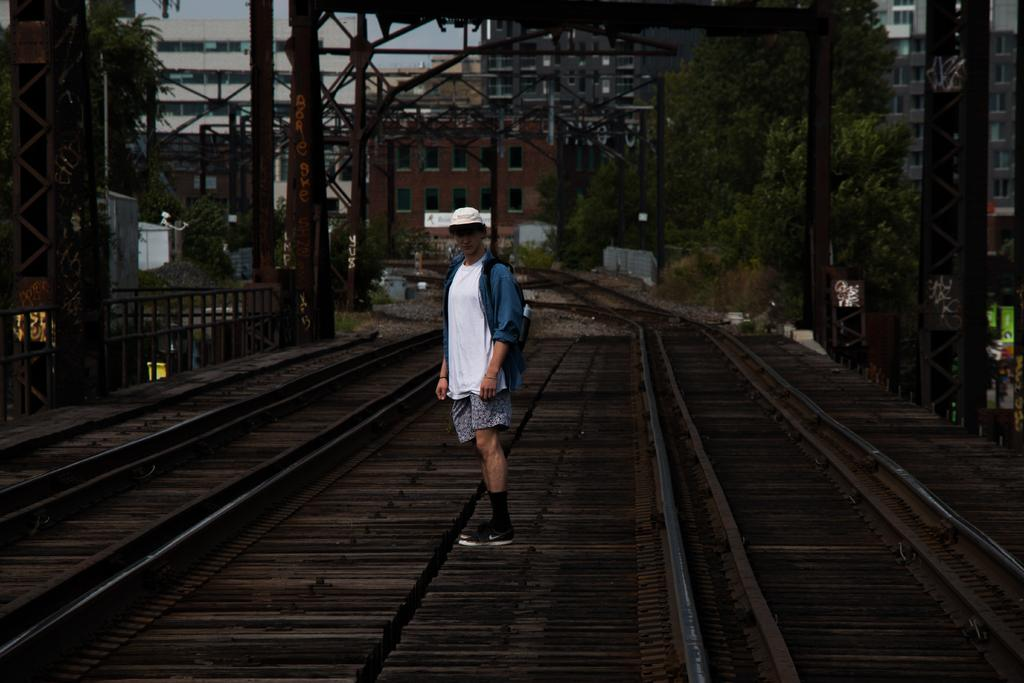What is the person in the image doing? The person is standing in between the tracks. What type of structures can be seen in the image? There are metal structures and poles in the image. What can be seen in the background of the image? There are trees and buildings in the background of the image. How much water is in the basin in the image? There is no basin present in the image, so it is not possible to determine the amount of water. 